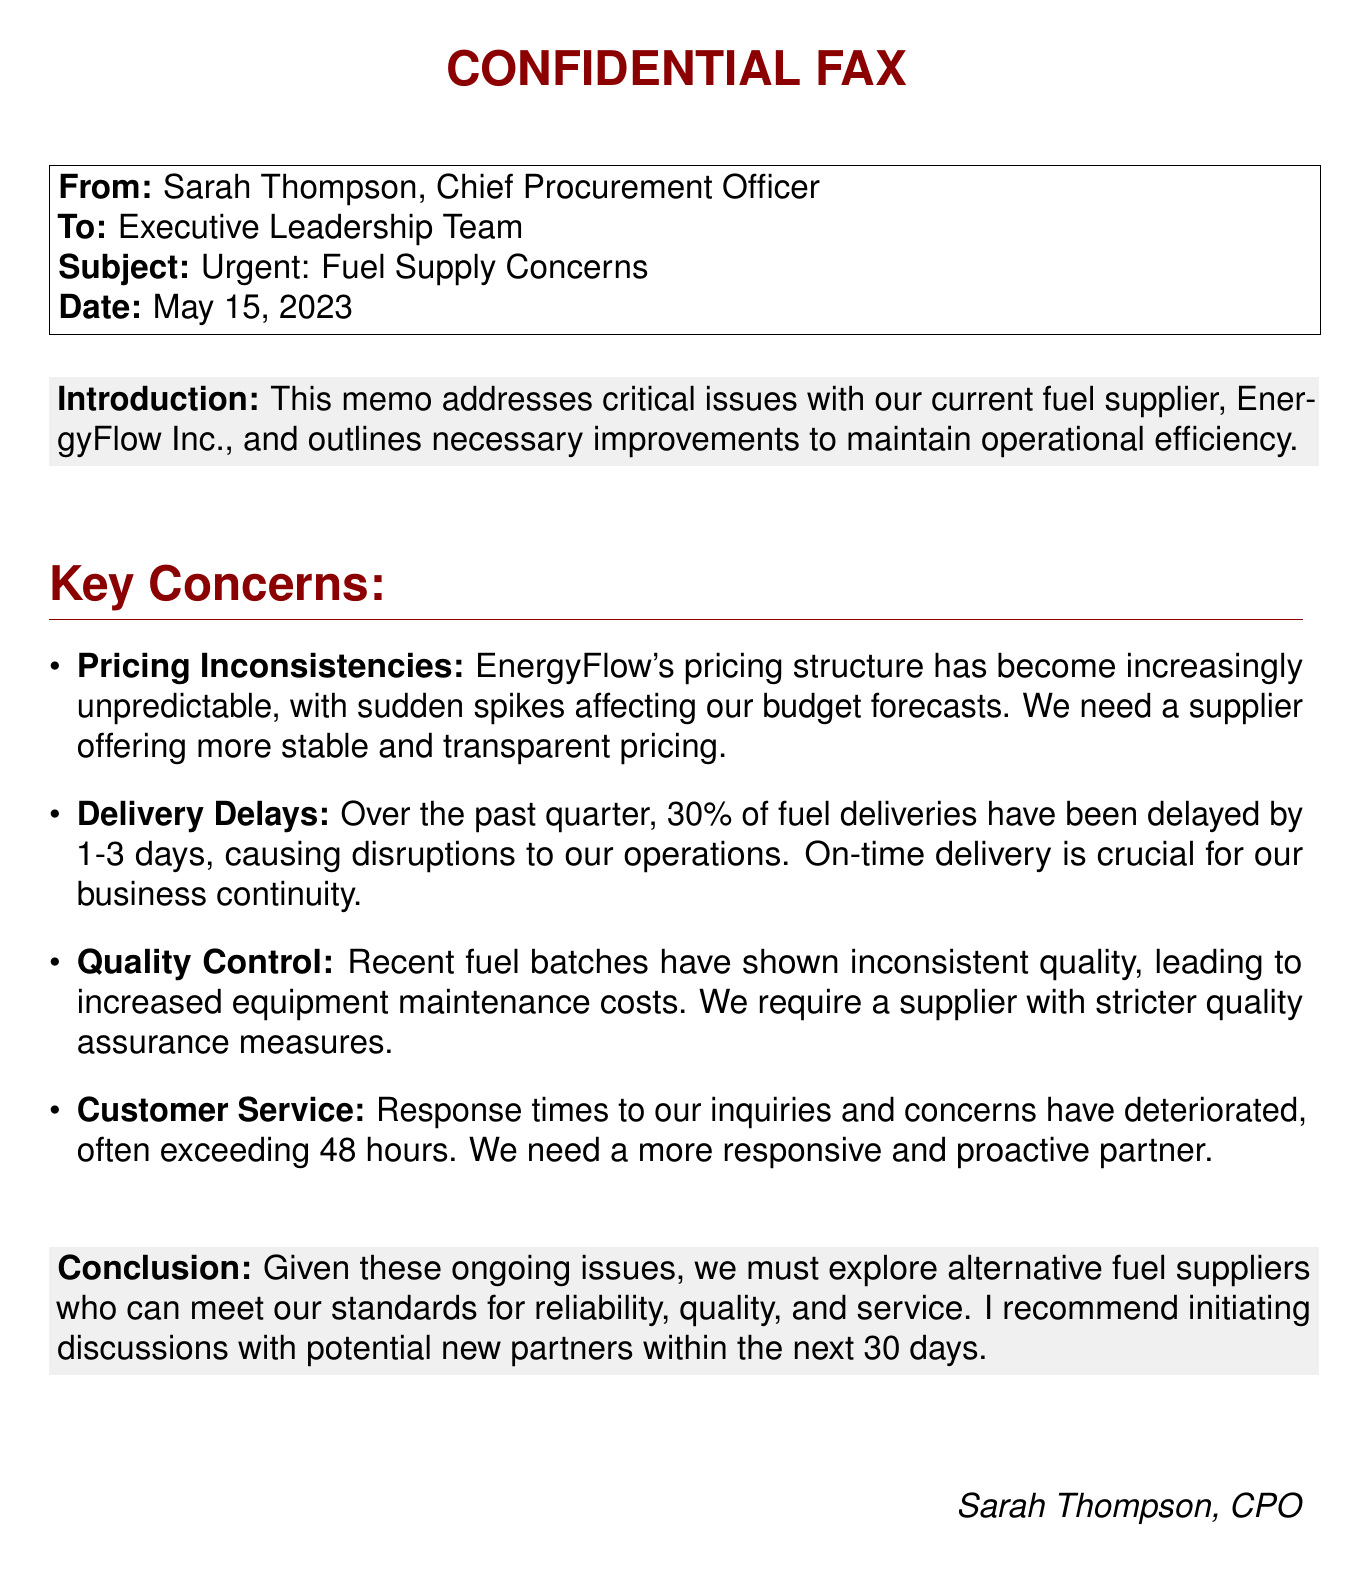what is the sender's name? The sender's name is mentioned in the fax header as Sarah Thompson.
Answer: Sarah Thompson what is the subject of the fax? The subject is provided in the fax header, indicating the focus of the memo.
Answer: Urgent: Fuel Supply Concerns what date was the memo sent? The date of the memo is explicitly stated in the fax header.
Answer: May 15, 2023 what percentage of deliveries were delayed? The memo specifies the percentage of fuel deliveries that were delayed over the past quarter.
Answer: 30% how long is the typical delivery delay mentioned? The memo outlines the duration of the delivery delays experienced.
Answer: 1-3 days what company is discussed in the memo? The memo identifies the current fuel supplier in question.
Answer: EnergyFlow Inc what is the response time to inquiries mentioned? The memo discusses the deteriorating response times for inquiries.
Answer: 48 hours what does the conclusion suggest? The conclusion of the memo gives a recommendation regarding future actions concerning suppliers.
Answer: Explore alternative fuel suppliers what area requires stricter measures according to the memo? The memo highlights a specific area that needs improvement related to product consistency.
Answer: Quality Control 